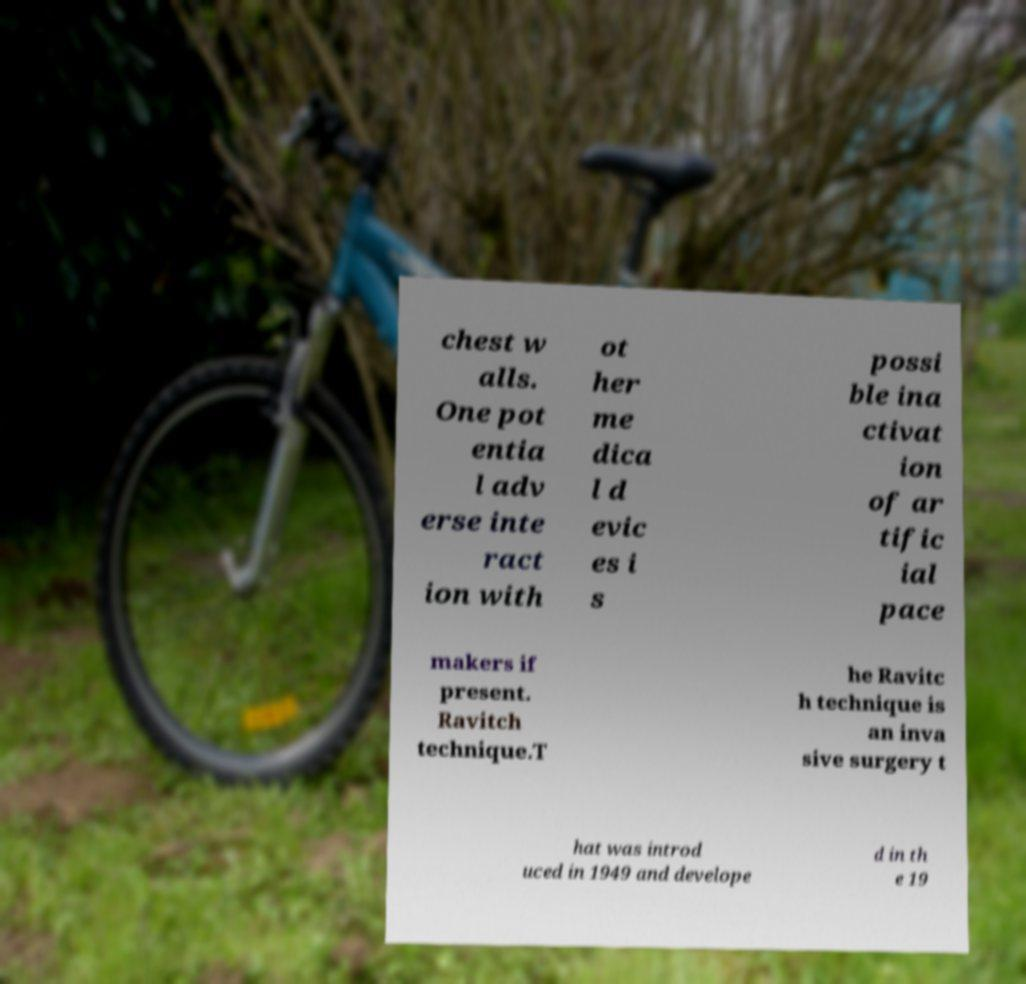Please read and relay the text visible in this image. What does it say? chest w alls. One pot entia l adv erse inte ract ion with ot her me dica l d evic es i s possi ble ina ctivat ion of ar tific ial pace makers if present. Ravitch technique.T he Ravitc h technique is an inva sive surgery t hat was introd uced in 1949 and develope d in th e 19 